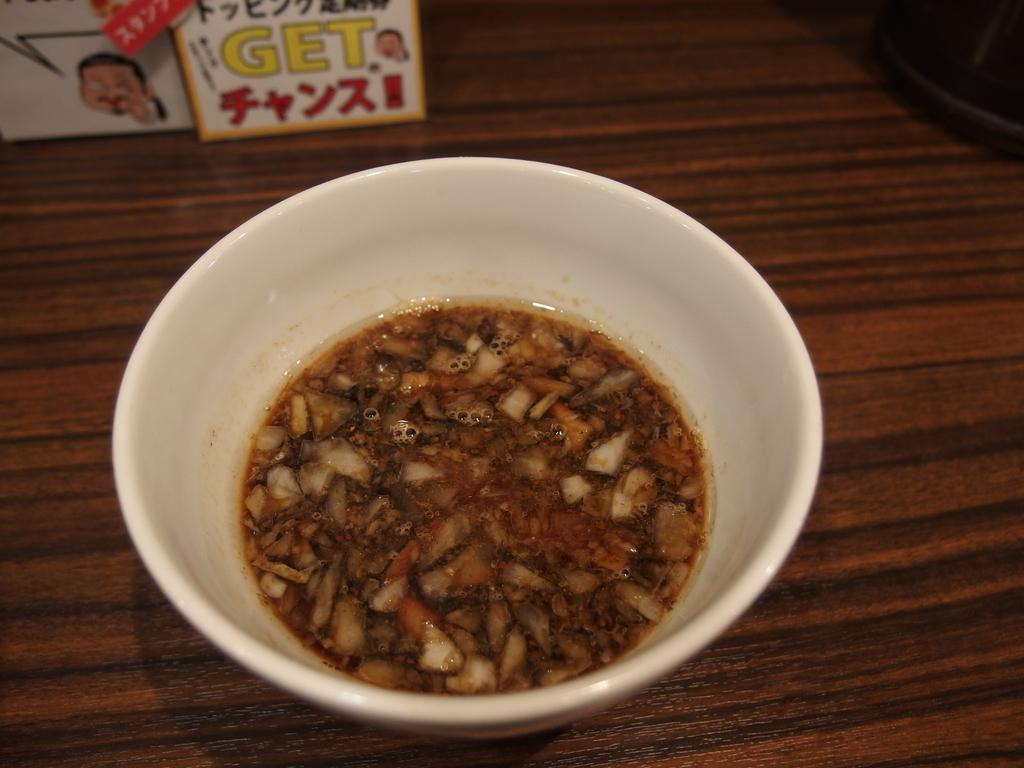Please provide a concise description of this image. On the table we can see food in a white bowl and there are other objects on the table. 